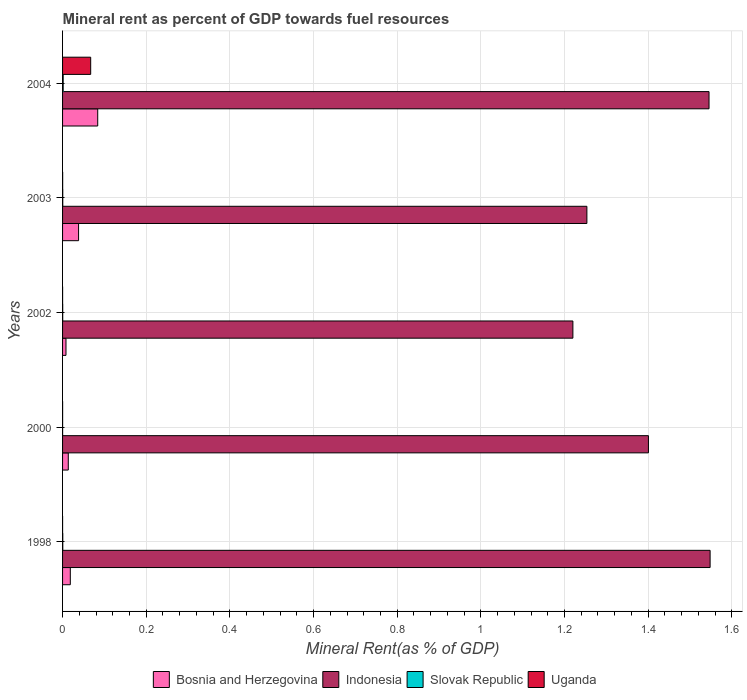How many groups of bars are there?
Offer a very short reply. 5. Are the number of bars per tick equal to the number of legend labels?
Make the answer very short. Yes. What is the label of the 2nd group of bars from the top?
Provide a succinct answer. 2003. What is the mineral rent in Indonesia in 2002?
Keep it short and to the point. 1.22. Across all years, what is the maximum mineral rent in Uganda?
Offer a terse response. 0.07. Across all years, what is the minimum mineral rent in Uganda?
Make the answer very short. 3.73694206195052e-5. In which year was the mineral rent in Indonesia maximum?
Provide a short and direct response. 1998. In which year was the mineral rent in Slovak Republic minimum?
Provide a succinct answer. 2000. What is the total mineral rent in Slovak Republic in the graph?
Your answer should be compact. 0. What is the difference between the mineral rent in Indonesia in 1998 and that in 2003?
Ensure brevity in your answer.  0.29. What is the difference between the mineral rent in Slovak Republic in 2004 and the mineral rent in Indonesia in 2003?
Offer a terse response. -1.25. What is the average mineral rent in Indonesia per year?
Provide a succinct answer. 1.39. In the year 2004, what is the difference between the mineral rent in Slovak Republic and mineral rent in Uganda?
Offer a very short reply. -0.07. What is the ratio of the mineral rent in Slovak Republic in 1998 to that in 2000?
Make the answer very short. 4.4. Is the mineral rent in Slovak Republic in 2003 less than that in 2004?
Offer a very short reply. Yes. Is the difference between the mineral rent in Slovak Republic in 2002 and 2003 greater than the difference between the mineral rent in Uganda in 2002 and 2003?
Provide a succinct answer. Yes. What is the difference between the highest and the second highest mineral rent in Bosnia and Herzegovina?
Make the answer very short. 0.05. What is the difference between the highest and the lowest mineral rent in Indonesia?
Provide a succinct answer. 0.33. In how many years, is the mineral rent in Bosnia and Herzegovina greater than the average mineral rent in Bosnia and Herzegovina taken over all years?
Provide a short and direct response. 2. Is the sum of the mineral rent in Bosnia and Herzegovina in 2000 and 2003 greater than the maximum mineral rent in Indonesia across all years?
Offer a very short reply. No. What does the 1st bar from the top in 1998 represents?
Provide a short and direct response. Uganda. What does the 4th bar from the bottom in 2000 represents?
Your answer should be compact. Uganda. Is it the case that in every year, the sum of the mineral rent in Indonesia and mineral rent in Bosnia and Herzegovina is greater than the mineral rent in Uganda?
Provide a short and direct response. Yes. Are all the bars in the graph horizontal?
Your answer should be very brief. Yes. What is the difference between two consecutive major ticks on the X-axis?
Give a very brief answer. 0.2. Does the graph contain any zero values?
Your response must be concise. No. Does the graph contain grids?
Offer a very short reply. Yes. How are the legend labels stacked?
Your answer should be very brief. Horizontal. What is the title of the graph?
Your answer should be compact. Mineral rent as percent of GDP towards fuel resources. Does "Mauritania" appear as one of the legend labels in the graph?
Ensure brevity in your answer.  No. What is the label or title of the X-axis?
Give a very brief answer. Mineral Rent(as % of GDP). What is the Mineral Rent(as % of GDP) of Bosnia and Herzegovina in 1998?
Offer a very short reply. 0.02. What is the Mineral Rent(as % of GDP) of Indonesia in 1998?
Provide a succinct answer. 1.55. What is the Mineral Rent(as % of GDP) in Slovak Republic in 1998?
Your answer should be very brief. 0. What is the Mineral Rent(as % of GDP) of Uganda in 1998?
Keep it short and to the point. 3.73694206195052e-5. What is the Mineral Rent(as % of GDP) in Bosnia and Herzegovina in 2000?
Your answer should be compact. 0.01. What is the Mineral Rent(as % of GDP) of Indonesia in 2000?
Your answer should be compact. 1.4. What is the Mineral Rent(as % of GDP) in Slovak Republic in 2000?
Your response must be concise. 0. What is the Mineral Rent(as % of GDP) in Uganda in 2000?
Provide a short and direct response. 0. What is the Mineral Rent(as % of GDP) of Bosnia and Herzegovina in 2002?
Offer a terse response. 0.01. What is the Mineral Rent(as % of GDP) of Indonesia in 2002?
Keep it short and to the point. 1.22. What is the Mineral Rent(as % of GDP) in Slovak Republic in 2002?
Give a very brief answer. 0. What is the Mineral Rent(as % of GDP) in Uganda in 2002?
Ensure brevity in your answer.  7.469620528345872e-5. What is the Mineral Rent(as % of GDP) in Bosnia and Herzegovina in 2003?
Give a very brief answer. 0.04. What is the Mineral Rent(as % of GDP) of Indonesia in 2003?
Ensure brevity in your answer.  1.25. What is the Mineral Rent(as % of GDP) in Slovak Republic in 2003?
Provide a succinct answer. 0. What is the Mineral Rent(as % of GDP) of Uganda in 2003?
Your response must be concise. 0. What is the Mineral Rent(as % of GDP) in Bosnia and Herzegovina in 2004?
Offer a very short reply. 0.08. What is the Mineral Rent(as % of GDP) of Indonesia in 2004?
Offer a terse response. 1.55. What is the Mineral Rent(as % of GDP) of Slovak Republic in 2004?
Make the answer very short. 0. What is the Mineral Rent(as % of GDP) in Uganda in 2004?
Provide a short and direct response. 0.07. Across all years, what is the maximum Mineral Rent(as % of GDP) of Bosnia and Herzegovina?
Provide a short and direct response. 0.08. Across all years, what is the maximum Mineral Rent(as % of GDP) in Indonesia?
Give a very brief answer. 1.55. Across all years, what is the maximum Mineral Rent(as % of GDP) of Slovak Republic?
Offer a very short reply. 0. Across all years, what is the maximum Mineral Rent(as % of GDP) in Uganda?
Your answer should be very brief. 0.07. Across all years, what is the minimum Mineral Rent(as % of GDP) of Bosnia and Herzegovina?
Provide a short and direct response. 0.01. Across all years, what is the minimum Mineral Rent(as % of GDP) in Indonesia?
Your response must be concise. 1.22. Across all years, what is the minimum Mineral Rent(as % of GDP) of Slovak Republic?
Provide a short and direct response. 0. Across all years, what is the minimum Mineral Rent(as % of GDP) of Uganda?
Make the answer very short. 3.73694206195052e-5. What is the total Mineral Rent(as % of GDP) in Bosnia and Herzegovina in the graph?
Keep it short and to the point. 0.16. What is the total Mineral Rent(as % of GDP) in Indonesia in the graph?
Your response must be concise. 6.97. What is the total Mineral Rent(as % of GDP) of Slovak Republic in the graph?
Make the answer very short. 0. What is the total Mineral Rent(as % of GDP) of Uganda in the graph?
Provide a short and direct response. 0.07. What is the difference between the Mineral Rent(as % of GDP) of Bosnia and Herzegovina in 1998 and that in 2000?
Give a very brief answer. 0. What is the difference between the Mineral Rent(as % of GDP) of Indonesia in 1998 and that in 2000?
Your answer should be compact. 0.15. What is the difference between the Mineral Rent(as % of GDP) in Uganda in 1998 and that in 2000?
Offer a terse response. -0. What is the difference between the Mineral Rent(as % of GDP) in Bosnia and Herzegovina in 1998 and that in 2002?
Your response must be concise. 0.01. What is the difference between the Mineral Rent(as % of GDP) of Indonesia in 1998 and that in 2002?
Your answer should be very brief. 0.33. What is the difference between the Mineral Rent(as % of GDP) of Slovak Republic in 1998 and that in 2002?
Offer a very short reply. 0. What is the difference between the Mineral Rent(as % of GDP) of Bosnia and Herzegovina in 1998 and that in 2003?
Ensure brevity in your answer.  -0.02. What is the difference between the Mineral Rent(as % of GDP) of Indonesia in 1998 and that in 2003?
Make the answer very short. 0.29. What is the difference between the Mineral Rent(as % of GDP) in Slovak Republic in 1998 and that in 2003?
Provide a succinct answer. 0. What is the difference between the Mineral Rent(as % of GDP) in Uganda in 1998 and that in 2003?
Ensure brevity in your answer.  -0. What is the difference between the Mineral Rent(as % of GDP) in Bosnia and Herzegovina in 1998 and that in 2004?
Provide a short and direct response. -0.07. What is the difference between the Mineral Rent(as % of GDP) in Indonesia in 1998 and that in 2004?
Keep it short and to the point. 0. What is the difference between the Mineral Rent(as % of GDP) in Slovak Republic in 1998 and that in 2004?
Provide a short and direct response. -0. What is the difference between the Mineral Rent(as % of GDP) in Uganda in 1998 and that in 2004?
Provide a succinct answer. -0.07. What is the difference between the Mineral Rent(as % of GDP) of Bosnia and Herzegovina in 2000 and that in 2002?
Offer a terse response. 0.01. What is the difference between the Mineral Rent(as % of GDP) of Indonesia in 2000 and that in 2002?
Your answer should be very brief. 0.18. What is the difference between the Mineral Rent(as % of GDP) in Slovak Republic in 2000 and that in 2002?
Ensure brevity in your answer.  -0. What is the difference between the Mineral Rent(as % of GDP) in Bosnia and Herzegovina in 2000 and that in 2003?
Give a very brief answer. -0.02. What is the difference between the Mineral Rent(as % of GDP) in Indonesia in 2000 and that in 2003?
Ensure brevity in your answer.  0.15. What is the difference between the Mineral Rent(as % of GDP) in Slovak Republic in 2000 and that in 2003?
Your answer should be compact. -0. What is the difference between the Mineral Rent(as % of GDP) of Uganda in 2000 and that in 2003?
Give a very brief answer. -0. What is the difference between the Mineral Rent(as % of GDP) in Bosnia and Herzegovina in 2000 and that in 2004?
Make the answer very short. -0.07. What is the difference between the Mineral Rent(as % of GDP) of Indonesia in 2000 and that in 2004?
Your answer should be compact. -0.14. What is the difference between the Mineral Rent(as % of GDP) of Slovak Republic in 2000 and that in 2004?
Provide a short and direct response. -0. What is the difference between the Mineral Rent(as % of GDP) of Uganda in 2000 and that in 2004?
Give a very brief answer. -0.07. What is the difference between the Mineral Rent(as % of GDP) of Bosnia and Herzegovina in 2002 and that in 2003?
Make the answer very short. -0.03. What is the difference between the Mineral Rent(as % of GDP) in Indonesia in 2002 and that in 2003?
Your answer should be very brief. -0.03. What is the difference between the Mineral Rent(as % of GDP) of Slovak Republic in 2002 and that in 2003?
Provide a succinct answer. -0. What is the difference between the Mineral Rent(as % of GDP) of Uganda in 2002 and that in 2003?
Offer a terse response. -0. What is the difference between the Mineral Rent(as % of GDP) of Bosnia and Herzegovina in 2002 and that in 2004?
Offer a terse response. -0.08. What is the difference between the Mineral Rent(as % of GDP) of Indonesia in 2002 and that in 2004?
Your answer should be compact. -0.33. What is the difference between the Mineral Rent(as % of GDP) of Slovak Republic in 2002 and that in 2004?
Ensure brevity in your answer.  -0. What is the difference between the Mineral Rent(as % of GDP) in Uganda in 2002 and that in 2004?
Give a very brief answer. -0.07. What is the difference between the Mineral Rent(as % of GDP) in Bosnia and Herzegovina in 2003 and that in 2004?
Your answer should be compact. -0.05. What is the difference between the Mineral Rent(as % of GDP) in Indonesia in 2003 and that in 2004?
Provide a succinct answer. -0.29. What is the difference between the Mineral Rent(as % of GDP) in Slovak Republic in 2003 and that in 2004?
Offer a very short reply. -0. What is the difference between the Mineral Rent(as % of GDP) of Uganda in 2003 and that in 2004?
Provide a succinct answer. -0.07. What is the difference between the Mineral Rent(as % of GDP) in Bosnia and Herzegovina in 1998 and the Mineral Rent(as % of GDP) in Indonesia in 2000?
Your answer should be compact. -1.38. What is the difference between the Mineral Rent(as % of GDP) of Bosnia and Herzegovina in 1998 and the Mineral Rent(as % of GDP) of Slovak Republic in 2000?
Keep it short and to the point. 0.02. What is the difference between the Mineral Rent(as % of GDP) of Bosnia and Herzegovina in 1998 and the Mineral Rent(as % of GDP) of Uganda in 2000?
Your response must be concise. 0.02. What is the difference between the Mineral Rent(as % of GDP) of Indonesia in 1998 and the Mineral Rent(as % of GDP) of Slovak Republic in 2000?
Provide a short and direct response. 1.55. What is the difference between the Mineral Rent(as % of GDP) in Indonesia in 1998 and the Mineral Rent(as % of GDP) in Uganda in 2000?
Give a very brief answer. 1.55. What is the difference between the Mineral Rent(as % of GDP) in Bosnia and Herzegovina in 1998 and the Mineral Rent(as % of GDP) in Indonesia in 2002?
Give a very brief answer. -1.2. What is the difference between the Mineral Rent(as % of GDP) in Bosnia and Herzegovina in 1998 and the Mineral Rent(as % of GDP) in Slovak Republic in 2002?
Your answer should be very brief. 0.02. What is the difference between the Mineral Rent(as % of GDP) of Bosnia and Herzegovina in 1998 and the Mineral Rent(as % of GDP) of Uganda in 2002?
Make the answer very short. 0.02. What is the difference between the Mineral Rent(as % of GDP) in Indonesia in 1998 and the Mineral Rent(as % of GDP) in Slovak Republic in 2002?
Ensure brevity in your answer.  1.55. What is the difference between the Mineral Rent(as % of GDP) of Indonesia in 1998 and the Mineral Rent(as % of GDP) of Uganda in 2002?
Give a very brief answer. 1.55. What is the difference between the Mineral Rent(as % of GDP) in Slovak Republic in 1998 and the Mineral Rent(as % of GDP) in Uganda in 2002?
Provide a succinct answer. 0. What is the difference between the Mineral Rent(as % of GDP) of Bosnia and Herzegovina in 1998 and the Mineral Rent(as % of GDP) of Indonesia in 2003?
Provide a short and direct response. -1.24. What is the difference between the Mineral Rent(as % of GDP) of Bosnia and Herzegovina in 1998 and the Mineral Rent(as % of GDP) of Slovak Republic in 2003?
Your answer should be very brief. 0.02. What is the difference between the Mineral Rent(as % of GDP) in Bosnia and Herzegovina in 1998 and the Mineral Rent(as % of GDP) in Uganda in 2003?
Ensure brevity in your answer.  0.02. What is the difference between the Mineral Rent(as % of GDP) in Indonesia in 1998 and the Mineral Rent(as % of GDP) in Slovak Republic in 2003?
Offer a terse response. 1.55. What is the difference between the Mineral Rent(as % of GDP) of Indonesia in 1998 and the Mineral Rent(as % of GDP) of Uganda in 2003?
Provide a succinct answer. 1.55. What is the difference between the Mineral Rent(as % of GDP) in Bosnia and Herzegovina in 1998 and the Mineral Rent(as % of GDP) in Indonesia in 2004?
Make the answer very short. -1.53. What is the difference between the Mineral Rent(as % of GDP) of Bosnia and Herzegovina in 1998 and the Mineral Rent(as % of GDP) of Slovak Republic in 2004?
Offer a very short reply. 0.02. What is the difference between the Mineral Rent(as % of GDP) of Bosnia and Herzegovina in 1998 and the Mineral Rent(as % of GDP) of Uganda in 2004?
Give a very brief answer. -0.05. What is the difference between the Mineral Rent(as % of GDP) in Indonesia in 1998 and the Mineral Rent(as % of GDP) in Slovak Republic in 2004?
Give a very brief answer. 1.55. What is the difference between the Mineral Rent(as % of GDP) in Indonesia in 1998 and the Mineral Rent(as % of GDP) in Uganda in 2004?
Your answer should be very brief. 1.48. What is the difference between the Mineral Rent(as % of GDP) of Slovak Republic in 1998 and the Mineral Rent(as % of GDP) of Uganda in 2004?
Your answer should be very brief. -0.07. What is the difference between the Mineral Rent(as % of GDP) in Bosnia and Herzegovina in 2000 and the Mineral Rent(as % of GDP) in Indonesia in 2002?
Your answer should be compact. -1.21. What is the difference between the Mineral Rent(as % of GDP) of Bosnia and Herzegovina in 2000 and the Mineral Rent(as % of GDP) of Slovak Republic in 2002?
Your response must be concise. 0.01. What is the difference between the Mineral Rent(as % of GDP) of Bosnia and Herzegovina in 2000 and the Mineral Rent(as % of GDP) of Uganda in 2002?
Your answer should be very brief. 0.01. What is the difference between the Mineral Rent(as % of GDP) in Indonesia in 2000 and the Mineral Rent(as % of GDP) in Slovak Republic in 2002?
Make the answer very short. 1.4. What is the difference between the Mineral Rent(as % of GDP) of Indonesia in 2000 and the Mineral Rent(as % of GDP) of Uganda in 2002?
Your answer should be very brief. 1.4. What is the difference between the Mineral Rent(as % of GDP) in Bosnia and Herzegovina in 2000 and the Mineral Rent(as % of GDP) in Indonesia in 2003?
Your answer should be very brief. -1.24. What is the difference between the Mineral Rent(as % of GDP) in Bosnia and Herzegovina in 2000 and the Mineral Rent(as % of GDP) in Slovak Republic in 2003?
Give a very brief answer. 0.01. What is the difference between the Mineral Rent(as % of GDP) in Bosnia and Herzegovina in 2000 and the Mineral Rent(as % of GDP) in Uganda in 2003?
Keep it short and to the point. 0.01. What is the difference between the Mineral Rent(as % of GDP) in Indonesia in 2000 and the Mineral Rent(as % of GDP) in Slovak Republic in 2003?
Provide a succinct answer. 1.4. What is the difference between the Mineral Rent(as % of GDP) of Indonesia in 2000 and the Mineral Rent(as % of GDP) of Uganda in 2003?
Ensure brevity in your answer.  1.4. What is the difference between the Mineral Rent(as % of GDP) of Slovak Republic in 2000 and the Mineral Rent(as % of GDP) of Uganda in 2003?
Offer a very short reply. -0. What is the difference between the Mineral Rent(as % of GDP) in Bosnia and Herzegovina in 2000 and the Mineral Rent(as % of GDP) in Indonesia in 2004?
Your answer should be very brief. -1.53. What is the difference between the Mineral Rent(as % of GDP) of Bosnia and Herzegovina in 2000 and the Mineral Rent(as % of GDP) of Slovak Republic in 2004?
Give a very brief answer. 0.01. What is the difference between the Mineral Rent(as % of GDP) in Bosnia and Herzegovina in 2000 and the Mineral Rent(as % of GDP) in Uganda in 2004?
Your answer should be compact. -0.05. What is the difference between the Mineral Rent(as % of GDP) in Indonesia in 2000 and the Mineral Rent(as % of GDP) in Slovak Republic in 2004?
Offer a terse response. 1.4. What is the difference between the Mineral Rent(as % of GDP) in Indonesia in 2000 and the Mineral Rent(as % of GDP) in Uganda in 2004?
Provide a succinct answer. 1.33. What is the difference between the Mineral Rent(as % of GDP) in Slovak Republic in 2000 and the Mineral Rent(as % of GDP) in Uganda in 2004?
Provide a short and direct response. -0.07. What is the difference between the Mineral Rent(as % of GDP) in Bosnia and Herzegovina in 2002 and the Mineral Rent(as % of GDP) in Indonesia in 2003?
Keep it short and to the point. -1.25. What is the difference between the Mineral Rent(as % of GDP) in Bosnia and Herzegovina in 2002 and the Mineral Rent(as % of GDP) in Slovak Republic in 2003?
Ensure brevity in your answer.  0.01. What is the difference between the Mineral Rent(as % of GDP) of Bosnia and Herzegovina in 2002 and the Mineral Rent(as % of GDP) of Uganda in 2003?
Give a very brief answer. 0.01. What is the difference between the Mineral Rent(as % of GDP) of Indonesia in 2002 and the Mineral Rent(as % of GDP) of Slovak Republic in 2003?
Your answer should be very brief. 1.22. What is the difference between the Mineral Rent(as % of GDP) of Indonesia in 2002 and the Mineral Rent(as % of GDP) of Uganda in 2003?
Give a very brief answer. 1.22. What is the difference between the Mineral Rent(as % of GDP) in Slovak Republic in 2002 and the Mineral Rent(as % of GDP) in Uganda in 2003?
Offer a terse response. 0. What is the difference between the Mineral Rent(as % of GDP) of Bosnia and Herzegovina in 2002 and the Mineral Rent(as % of GDP) of Indonesia in 2004?
Offer a very short reply. -1.54. What is the difference between the Mineral Rent(as % of GDP) of Bosnia and Herzegovina in 2002 and the Mineral Rent(as % of GDP) of Slovak Republic in 2004?
Give a very brief answer. 0.01. What is the difference between the Mineral Rent(as % of GDP) in Bosnia and Herzegovina in 2002 and the Mineral Rent(as % of GDP) in Uganda in 2004?
Keep it short and to the point. -0.06. What is the difference between the Mineral Rent(as % of GDP) in Indonesia in 2002 and the Mineral Rent(as % of GDP) in Slovak Republic in 2004?
Provide a short and direct response. 1.22. What is the difference between the Mineral Rent(as % of GDP) of Indonesia in 2002 and the Mineral Rent(as % of GDP) of Uganda in 2004?
Keep it short and to the point. 1.15. What is the difference between the Mineral Rent(as % of GDP) in Slovak Republic in 2002 and the Mineral Rent(as % of GDP) in Uganda in 2004?
Your answer should be very brief. -0.07. What is the difference between the Mineral Rent(as % of GDP) of Bosnia and Herzegovina in 2003 and the Mineral Rent(as % of GDP) of Indonesia in 2004?
Provide a short and direct response. -1.51. What is the difference between the Mineral Rent(as % of GDP) in Bosnia and Herzegovina in 2003 and the Mineral Rent(as % of GDP) in Slovak Republic in 2004?
Offer a terse response. 0.04. What is the difference between the Mineral Rent(as % of GDP) in Bosnia and Herzegovina in 2003 and the Mineral Rent(as % of GDP) in Uganda in 2004?
Make the answer very short. -0.03. What is the difference between the Mineral Rent(as % of GDP) of Indonesia in 2003 and the Mineral Rent(as % of GDP) of Slovak Republic in 2004?
Ensure brevity in your answer.  1.25. What is the difference between the Mineral Rent(as % of GDP) in Indonesia in 2003 and the Mineral Rent(as % of GDP) in Uganda in 2004?
Your response must be concise. 1.19. What is the difference between the Mineral Rent(as % of GDP) of Slovak Republic in 2003 and the Mineral Rent(as % of GDP) of Uganda in 2004?
Your answer should be compact. -0.07. What is the average Mineral Rent(as % of GDP) of Bosnia and Herzegovina per year?
Offer a terse response. 0.03. What is the average Mineral Rent(as % of GDP) of Indonesia per year?
Your response must be concise. 1.39. What is the average Mineral Rent(as % of GDP) of Slovak Republic per year?
Provide a succinct answer. 0. What is the average Mineral Rent(as % of GDP) of Uganda per year?
Offer a very short reply. 0.01. In the year 1998, what is the difference between the Mineral Rent(as % of GDP) of Bosnia and Herzegovina and Mineral Rent(as % of GDP) of Indonesia?
Your response must be concise. -1.53. In the year 1998, what is the difference between the Mineral Rent(as % of GDP) of Bosnia and Herzegovina and Mineral Rent(as % of GDP) of Slovak Republic?
Provide a short and direct response. 0.02. In the year 1998, what is the difference between the Mineral Rent(as % of GDP) in Bosnia and Herzegovina and Mineral Rent(as % of GDP) in Uganda?
Offer a terse response. 0.02. In the year 1998, what is the difference between the Mineral Rent(as % of GDP) in Indonesia and Mineral Rent(as % of GDP) in Slovak Republic?
Offer a very short reply. 1.55. In the year 1998, what is the difference between the Mineral Rent(as % of GDP) of Indonesia and Mineral Rent(as % of GDP) of Uganda?
Provide a short and direct response. 1.55. In the year 1998, what is the difference between the Mineral Rent(as % of GDP) in Slovak Republic and Mineral Rent(as % of GDP) in Uganda?
Give a very brief answer. 0. In the year 2000, what is the difference between the Mineral Rent(as % of GDP) of Bosnia and Herzegovina and Mineral Rent(as % of GDP) of Indonesia?
Offer a terse response. -1.39. In the year 2000, what is the difference between the Mineral Rent(as % of GDP) of Bosnia and Herzegovina and Mineral Rent(as % of GDP) of Slovak Republic?
Offer a terse response. 0.01. In the year 2000, what is the difference between the Mineral Rent(as % of GDP) of Bosnia and Herzegovina and Mineral Rent(as % of GDP) of Uganda?
Offer a terse response. 0.01. In the year 2000, what is the difference between the Mineral Rent(as % of GDP) in Indonesia and Mineral Rent(as % of GDP) in Slovak Republic?
Provide a succinct answer. 1.4. In the year 2000, what is the difference between the Mineral Rent(as % of GDP) in Indonesia and Mineral Rent(as % of GDP) in Uganda?
Offer a terse response. 1.4. In the year 2000, what is the difference between the Mineral Rent(as % of GDP) in Slovak Republic and Mineral Rent(as % of GDP) in Uganda?
Provide a short and direct response. 0. In the year 2002, what is the difference between the Mineral Rent(as % of GDP) of Bosnia and Herzegovina and Mineral Rent(as % of GDP) of Indonesia?
Provide a succinct answer. -1.21. In the year 2002, what is the difference between the Mineral Rent(as % of GDP) of Bosnia and Herzegovina and Mineral Rent(as % of GDP) of Slovak Republic?
Your answer should be very brief. 0.01. In the year 2002, what is the difference between the Mineral Rent(as % of GDP) in Bosnia and Herzegovina and Mineral Rent(as % of GDP) in Uganda?
Keep it short and to the point. 0.01. In the year 2002, what is the difference between the Mineral Rent(as % of GDP) of Indonesia and Mineral Rent(as % of GDP) of Slovak Republic?
Ensure brevity in your answer.  1.22. In the year 2002, what is the difference between the Mineral Rent(as % of GDP) of Indonesia and Mineral Rent(as % of GDP) of Uganda?
Your response must be concise. 1.22. In the year 2003, what is the difference between the Mineral Rent(as % of GDP) in Bosnia and Herzegovina and Mineral Rent(as % of GDP) in Indonesia?
Your response must be concise. -1.22. In the year 2003, what is the difference between the Mineral Rent(as % of GDP) of Bosnia and Herzegovina and Mineral Rent(as % of GDP) of Slovak Republic?
Your answer should be compact. 0.04. In the year 2003, what is the difference between the Mineral Rent(as % of GDP) of Bosnia and Herzegovina and Mineral Rent(as % of GDP) of Uganda?
Your response must be concise. 0.04. In the year 2003, what is the difference between the Mineral Rent(as % of GDP) in Indonesia and Mineral Rent(as % of GDP) in Slovak Republic?
Ensure brevity in your answer.  1.25. In the year 2003, what is the difference between the Mineral Rent(as % of GDP) of Indonesia and Mineral Rent(as % of GDP) of Uganda?
Keep it short and to the point. 1.25. In the year 2003, what is the difference between the Mineral Rent(as % of GDP) of Slovak Republic and Mineral Rent(as % of GDP) of Uganda?
Keep it short and to the point. 0. In the year 2004, what is the difference between the Mineral Rent(as % of GDP) in Bosnia and Herzegovina and Mineral Rent(as % of GDP) in Indonesia?
Keep it short and to the point. -1.46. In the year 2004, what is the difference between the Mineral Rent(as % of GDP) of Bosnia and Herzegovina and Mineral Rent(as % of GDP) of Slovak Republic?
Offer a terse response. 0.08. In the year 2004, what is the difference between the Mineral Rent(as % of GDP) in Bosnia and Herzegovina and Mineral Rent(as % of GDP) in Uganda?
Your answer should be very brief. 0.02. In the year 2004, what is the difference between the Mineral Rent(as % of GDP) in Indonesia and Mineral Rent(as % of GDP) in Slovak Republic?
Give a very brief answer. 1.54. In the year 2004, what is the difference between the Mineral Rent(as % of GDP) in Indonesia and Mineral Rent(as % of GDP) in Uganda?
Your answer should be compact. 1.48. In the year 2004, what is the difference between the Mineral Rent(as % of GDP) in Slovak Republic and Mineral Rent(as % of GDP) in Uganda?
Give a very brief answer. -0.07. What is the ratio of the Mineral Rent(as % of GDP) in Bosnia and Herzegovina in 1998 to that in 2000?
Your answer should be very brief. 1.36. What is the ratio of the Mineral Rent(as % of GDP) of Indonesia in 1998 to that in 2000?
Offer a terse response. 1.11. What is the ratio of the Mineral Rent(as % of GDP) in Slovak Republic in 1998 to that in 2000?
Ensure brevity in your answer.  4.4. What is the ratio of the Mineral Rent(as % of GDP) in Uganda in 1998 to that in 2000?
Offer a terse response. 0.37. What is the ratio of the Mineral Rent(as % of GDP) in Bosnia and Herzegovina in 1998 to that in 2002?
Provide a succinct answer. 2.26. What is the ratio of the Mineral Rent(as % of GDP) of Indonesia in 1998 to that in 2002?
Provide a short and direct response. 1.27. What is the ratio of the Mineral Rent(as % of GDP) in Slovak Republic in 1998 to that in 2002?
Your answer should be very brief. 1.54. What is the ratio of the Mineral Rent(as % of GDP) of Uganda in 1998 to that in 2002?
Provide a succinct answer. 0.5. What is the ratio of the Mineral Rent(as % of GDP) of Bosnia and Herzegovina in 1998 to that in 2003?
Your answer should be compact. 0.48. What is the ratio of the Mineral Rent(as % of GDP) in Indonesia in 1998 to that in 2003?
Ensure brevity in your answer.  1.24. What is the ratio of the Mineral Rent(as % of GDP) of Slovak Republic in 1998 to that in 2003?
Ensure brevity in your answer.  1.15. What is the ratio of the Mineral Rent(as % of GDP) of Uganda in 1998 to that in 2003?
Make the answer very short. 0.17. What is the ratio of the Mineral Rent(as % of GDP) in Bosnia and Herzegovina in 1998 to that in 2004?
Offer a terse response. 0.22. What is the ratio of the Mineral Rent(as % of GDP) of Slovak Republic in 1998 to that in 2004?
Keep it short and to the point. 0.35. What is the ratio of the Mineral Rent(as % of GDP) of Uganda in 1998 to that in 2004?
Your answer should be compact. 0. What is the ratio of the Mineral Rent(as % of GDP) in Bosnia and Herzegovina in 2000 to that in 2002?
Keep it short and to the point. 1.67. What is the ratio of the Mineral Rent(as % of GDP) in Indonesia in 2000 to that in 2002?
Your answer should be very brief. 1.15. What is the ratio of the Mineral Rent(as % of GDP) of Slovak Republic in 2000 to that in 2002?
Your response must be concise. 0.35. What is the ratio of the Mineral Rent(as % of GDP) of Uganda in 2000 to that in 2002?
Keep it short and to the point. 1.36. What is the ratio of the Mineral Rent(as % of GDP) of Bosnia and Herzegovina in 2000 to that in 2003?
Ensure brevity in your answer.  0.36. What is the ratio of the Mineral Rent(as % of GDP) in Indonesia in 2000 to that in 2003?
Give a very brief answer. 1.12. What is the ratio of the Mineral Rent(as % of GDP) of Slovak Republic in 2000 to that in 2003?
Ensure brevity in your answer.  0.26. What is the ratio of the Mineral Rent(as % of GDP) of Uganda in 2000 to that in 2003?
Offer a terse response. 0.45. What is the ratio of the Mineral Rent(as % of GDP) in Bosnia and Herzegovina in 2000 to that in 2004?
Your answer should be very brief. 0.16. What is the ratio of the Mineral Rent(as % of GDP) of Indonesia in 2000 to that in 2004?
Provide a succinct answer. 0.91. What is the ratio of the Mineral Rent(as % of GDP) in Slovak Republic in 2000 to that in 2004?
Your answer should be very brief. 0.08. What is the ratio of the Mineral Rent(as % of GDP) of Uganda in 2000 to that in 2004?
Offer a very short reply. 0. What is the ratio of the Mineral Rent(as % of GDP) in Bosnia and Herzegovina in 2002 to that in 2003?
Keep it short and to the point. 0.21. What is the ratio of the Mineral Rent(as % of GDP) of Indonesia in 2002 to that in 2003?
Your answer should be very brief. 0.97. What is the ratio of the Mineral Rent(as % of GDP) in Slovak Republic in 2002 to that in 2003?
Offer a terse response. 0.75. What is the ratio of the Mineral Rent(as % of GDP) of Uganda in 2002 to that in 2003?
Your response must be concise. 0.34. What is the ratio of the Mineral Rent(as % of GDP) of Bosnia and Herzegovina in 2002 to that in 2004?
Your answer should be very brief. 0.1. What is the ratio of the Mineral Rent(as % of GDP) in Indonesia in 2002 to that in 2004?
Offer a terse response. 0.79. What is the ratio of the Mineral Rent(as % of GDP) in Slovak Republic in 2002 to that in 2004?
Your answer should be very brief. 0.23. What is the ratio of the Mineral Rent(as % of GDP) in Uganda in 2002 to that in 2004?
Your answer should be compact. 0. What is the ratio of the Mineral Rent(as % of GDP) of Bosnia and Herzegovina in 2003 to that in 2004?
Provide a succinct answer. 0.46. What is the ratio of the Mineral Rent(as % of GDP) in Indonesia in 2003 to that in 2004?
Your answer should be compact. 0.81. What is the ratio of the Mineral Rent(as % of GDP) of Slovak Republic in 2003 to that in 2004?
Provide a succinct answer. 0.31. What is the ratio of the Mineral Rent(as % of GDP) of Uganda in 2003 to that in 2004?
Your answer should be very brief. 0. What is the difference between the highest and the second highest Mineral Rent(as % of GDP) of Bosnia and Herzegovina?
Your answer should be compact. 0.05. What is the difference between the highest and the second highest Mineral Rent(as % of GDP) in Indonesia?
Keep it short and to the point. 0. What is the difference between the highest and the second highest Mineral Rent(as % of GDP) of Slovak Republic?
Your response must be concise. 0. What is the difference between the highest and the second highest Mineral Rent(as % of GDP) of Uganda?
Ensure brevity in your answer.  0.07. What is the difference between the highest and the lowest Mineral Rent(as % of GDP) in Bosnia and Herzegovina?
Offer a very short reply. 0.08. What is the difference between the highest and the lowest Mineral Rent(as % of GDP) in Indonesia?
Provide a succinct answer. 0.33. What is the difference between the highest and the lowest Mineral Rent(as % of GDP) in Slovak Republic?
Provide a short and direct response. 0. What is the difference between the highest and the lowest Mineral Rent(as % of GDP) in Uganda?
Your answer should be very brief. 0.07. 